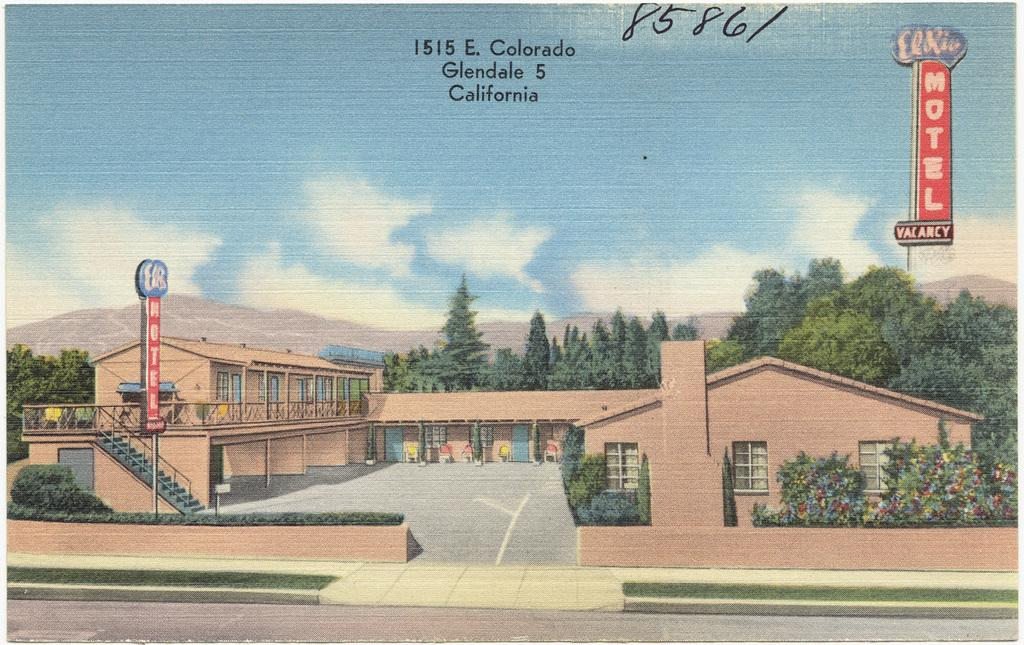What is the main subject of the picture in the image? The picture contains various elements, including sky with clouds, text, name boards, stairs, railings, buildings, trees, hills, a chimney, bushes, grass, and a road. Can you describe the sky in the picture? The sky in the picture includes clouds. What type of text is present in the picture? The text in the picture is not specified, but it is mentioned as a part of the image. Are there any architectural features visible in the picture? Yes, stairs, railings, and buildings are visible in the picture. What natural elements can be seen in the picture? Trees, hills, bushes, grass, and a road are natural elements present in the picture. Is there any man-made structure visible in the picture? Yes, name boards and a chimney are man-made structures visible in the picture. How many wax candles are present in the picture? There is no mention of wax candles in the provided facts, so it cannot be determined if any are present in the image. 